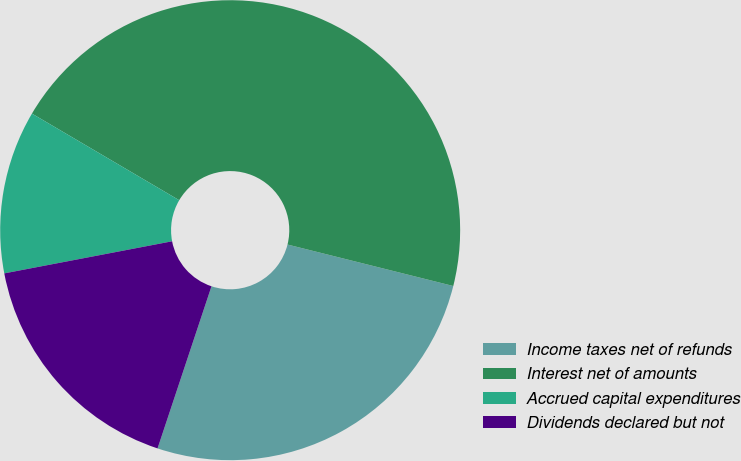<chart> <loc_0><loc_0><loc_500><loc_500><pie_chart><fcel>Income taxes net of refunds<fcel>Interest net of amounts<fcel>Accrued capital expenditures<fcel>Dividends declared but not<nl><fcel>26.21%<fcel>45.44%<fcel>11.47%<fcel>16.88%<nl></chart> 